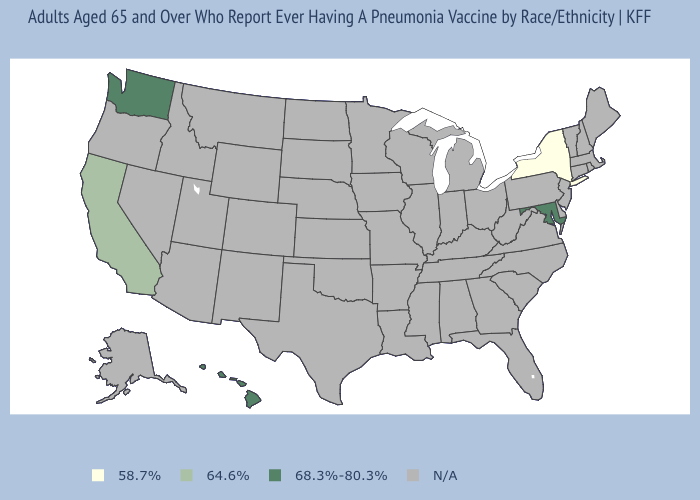What is the value of Oregon?
Be succinct. N/A. Name the states that have a value in the range 58.7%?
Keep it brief. New York. How many symbols are there in the legend?
Be succinct. 4. Does New York have the lowest value in the USA?
Concise answer only. Yes. Does the first symbol in the legend represent the smallest category?
Write a very short answer. Yes. What is the value of Iowa?
Quick response, please. N/A. What is the value of Alabama?
Keep it brief. N/A. Is the legend a continuous bar?
Keep it brief. No. What is the lowest value in the West?
Concise answer only. 64.6%. Name the states that have a value in the range 58.7%?
Keep it brief. New York. Name the states that have a value in the range 68.3%-80.3%?
Short answer required. Hawaii, Maryland, Washington. Which states have the lowest value in the Northeast?
Short answer required. New York. 